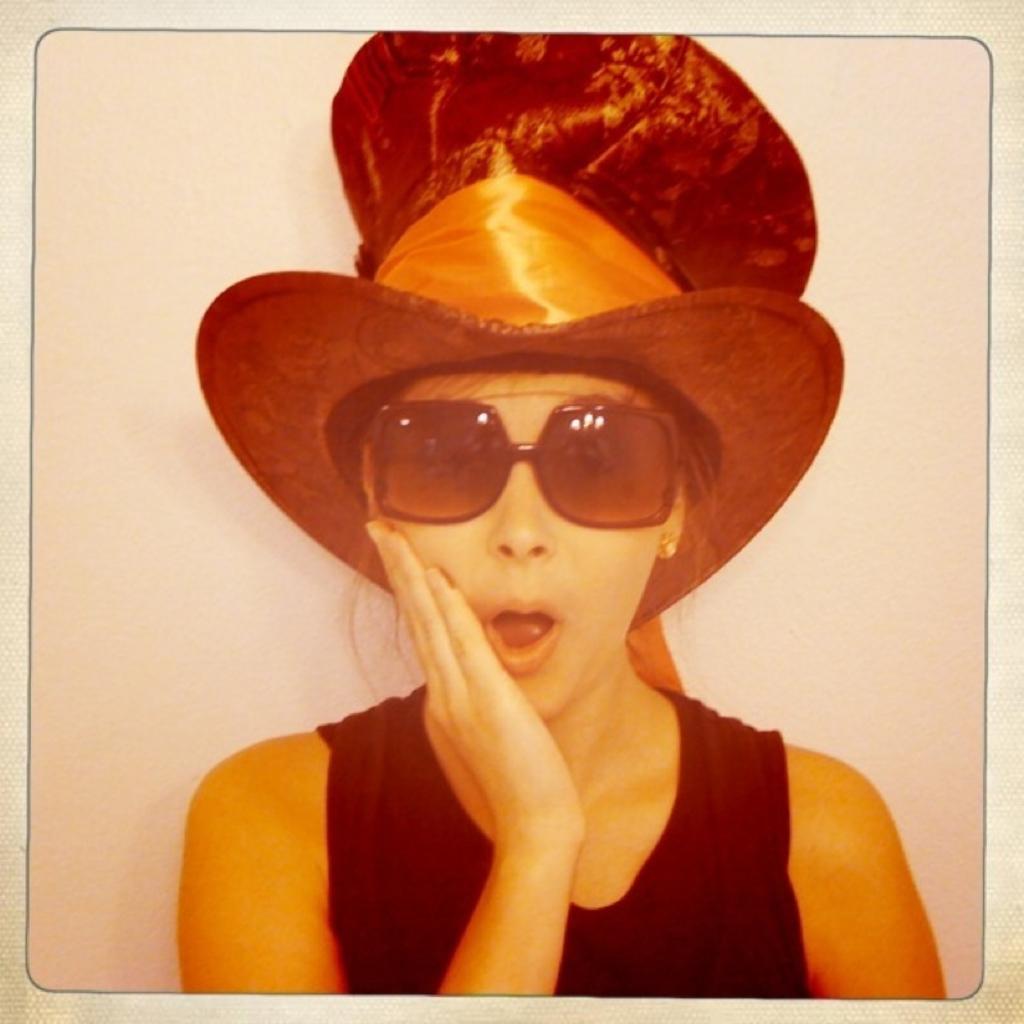Can you describe this image briefly? In the center of the image we can see a lady. She is wearing a hat. In the background there is a wall. 